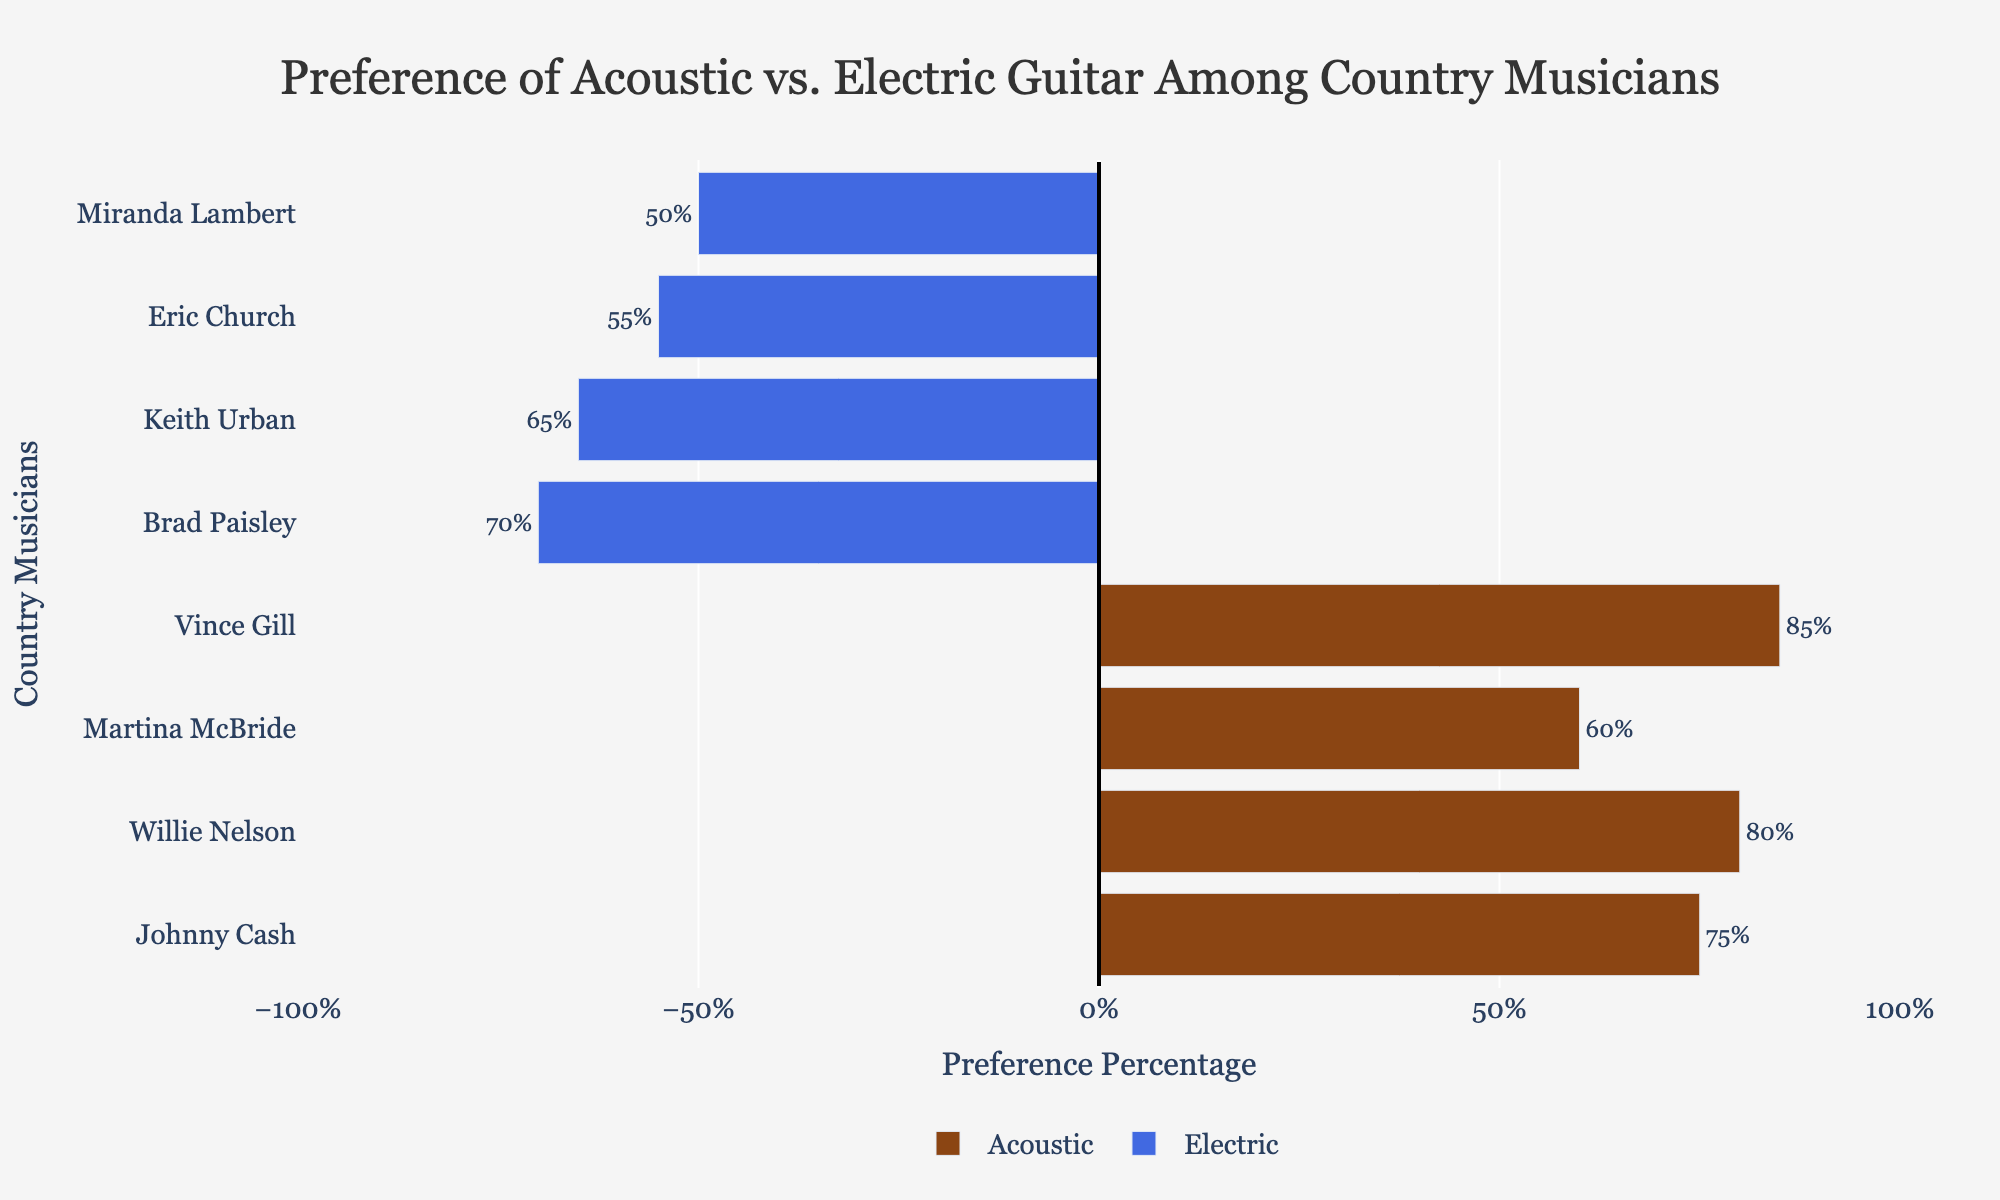Which musician has the highest preference for acoustic guitar? Vince Gill has the highest preference for acoustic guitar at 85%.
Answer: Vince Gill Between Johnny Cash and Brad Paisley, who has a higher preference percentage, and for which type of guitar? Johnny Cash has a higher preference percentage at 75% for acoustic guitar, while Brad Paisley has 70% for electric guitar.
Answer: Johnny Cash for acoustic guitar What is the total preference percentage for acoustic guitars among all listed musicians? Adding up the percentages for acoustic guitars: 75 (Johnny Cash) + 80 (Willie Nelson) + 60 (Martina McBride) + 85 (Vince Gill) = 300.
Answer: 300% Compare the preference between Keith Urban and Miranda Lambert. Who has a higher preference percentage and for which guitar? Keith Urban has a higher preference at 65% for electric guitar, compared to Miranda Lambert's 50% for electric guitar.
Answer: Keith Urban for electric guitar Which musician has the lowest preference for electric guitar, and what percentage is it? Miranda Lambert has the lowest preference for electric guitar at 50%.
Answer: Miranda Lambert How does the preference for acoustic guitars by Willie Nelson compare to that by Vince Gill? Willie Nelson has a preference of 80% for acoustic guitar, whereas Vince Gill has a preference of 85%, making Vince Gill's preference 5% higher than Willie Nelson's.
Answer: Vince Gill What is the average preference percentage for electric guitars among the listed musicians? Adding up the percentages for electric guitars: 70 (Brad Paisley) + 65 (Keith Urban) + 55 (Eric Church) + 50 (Miranda Lambert) = 240. Dividing by 4 gives an average of 60%.
Answer: 60% Which musicians have a preference percentage above 70% for their respective guitars, and what are these percentages? Johnny Cash (75% acoustic), Willie Nelson (80% acoustic), and Vince Gill (85% acoustic) have preferences above 70% for their respective guitars.
Answer: Johnny Cash (75%), Willie Nelson (80%), Vince Gill (85%) What is the difference in preference percentage between the musician with the highest and the musician with the lowest preference for acoustic guitar? The highest preference for acoustic guitar is 85% (Vince Gill) and the lowest is 60% (Martina McBride). The difference is 85% - 60% = 25%.
Answer: 25% Between Martina McBride and Eric Church, who has a higher overall preference percentage, and by how much? Martina McBride has a preference of 60% for acoustic guitar, while Eric Church has 55% for electric guitar. The difference is 60% - 55% = 5%.
Answer: Martina McBride by 5% 